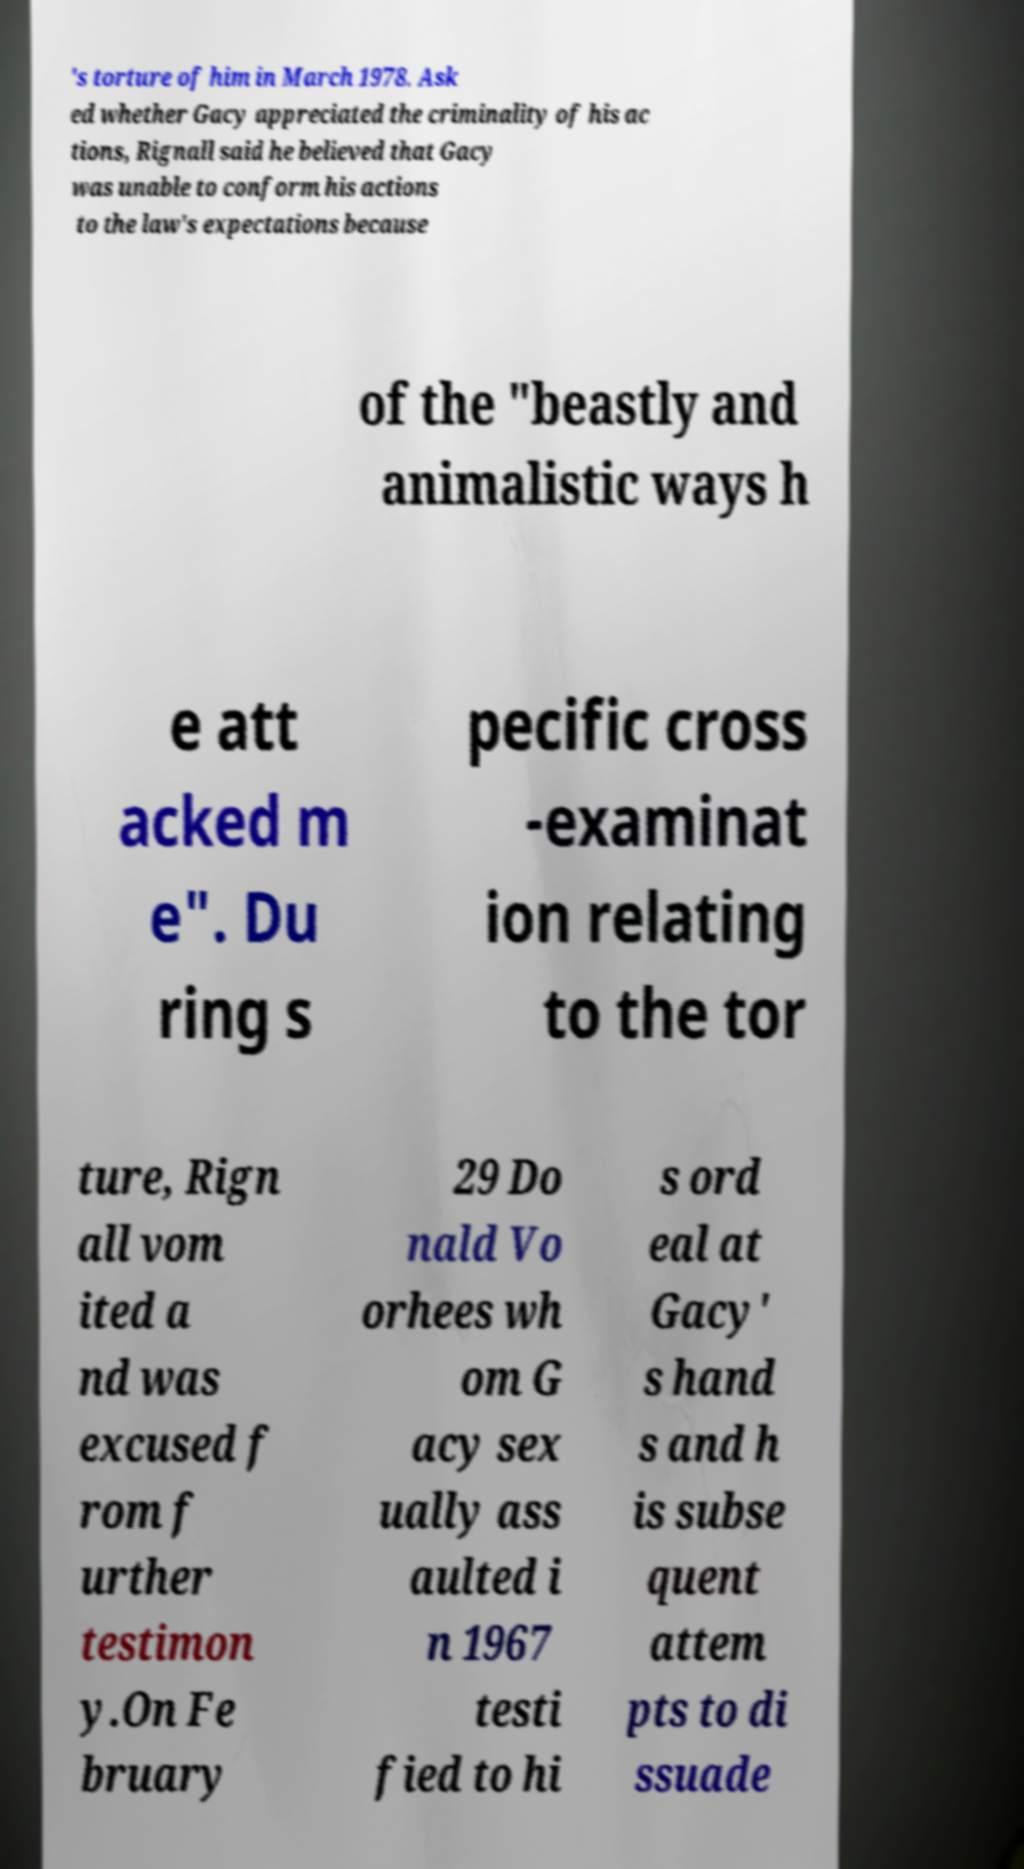Please identify and transcribe the text found in this image. 's torture of him in March 1978. Ask ed whether Gacy appreciated the criminality of his ac tions, Rignall said he believed that Gacy was unable to conform his actions to the law's expectations because of the "beastly and animalistic ways h e att acked m e". Du ring s pecific cross -examinat ion relating to the tor ture, Rign all vom ited a nd was excused f rom f urther testimon y.On Fe bruary 29 Do nald Vo orhees wh om G acy sex ually ass aulted i n 1967 testi fied to hi s ord eal at Gacy' s hand s and h is subse quent attem pts to di ssuade 